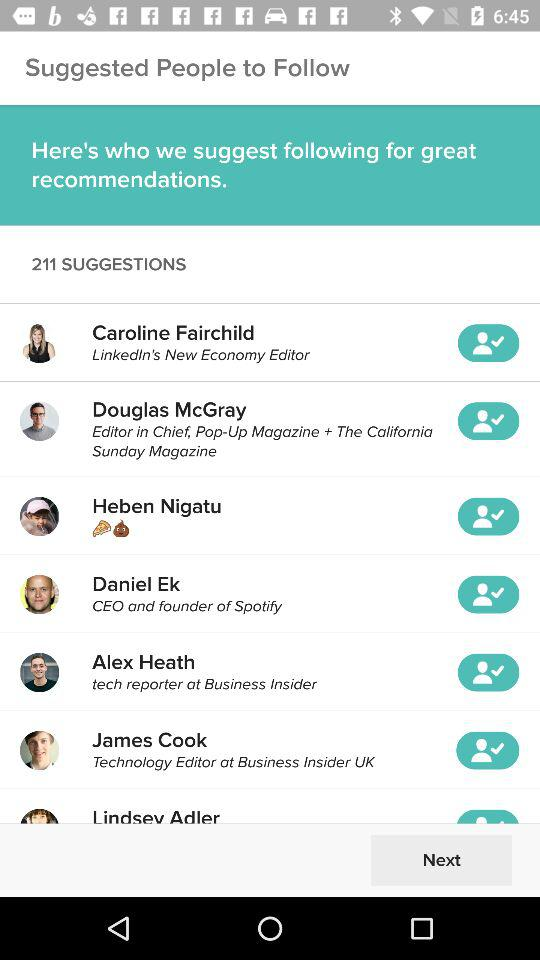How many people are suggested to follow?
Answer the question using a single word or phrase. 211 